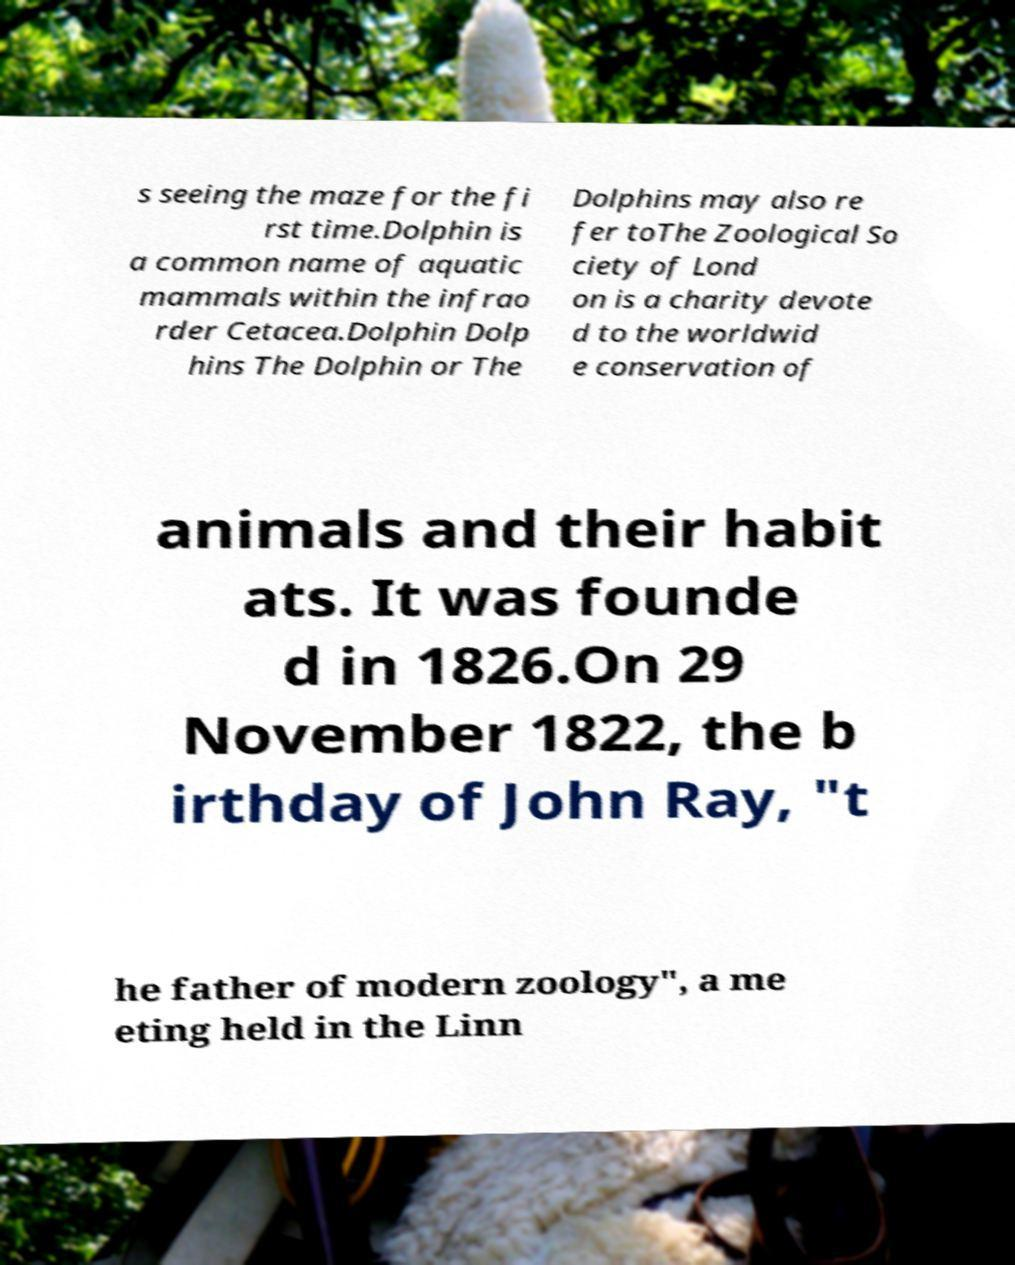There's text embedded in this image that I need extracted. Can you transcribe it verbatim? s seeing the maze for the fi rst time.Dolphin is a common name of aquatic mammals within the infrao rder Cetacea.Dolphin Dolp hins The Dolphin or The Dolphins may also re fer toThe Zoological So ciety of Lond on is a charity devote d to the worldwid e conservation of animals and their habit ats. It was founde d in 1826.On 29 November 1822, the b irthday of John Ray, "t he father of modern zoology", a me eting held in the Linn 